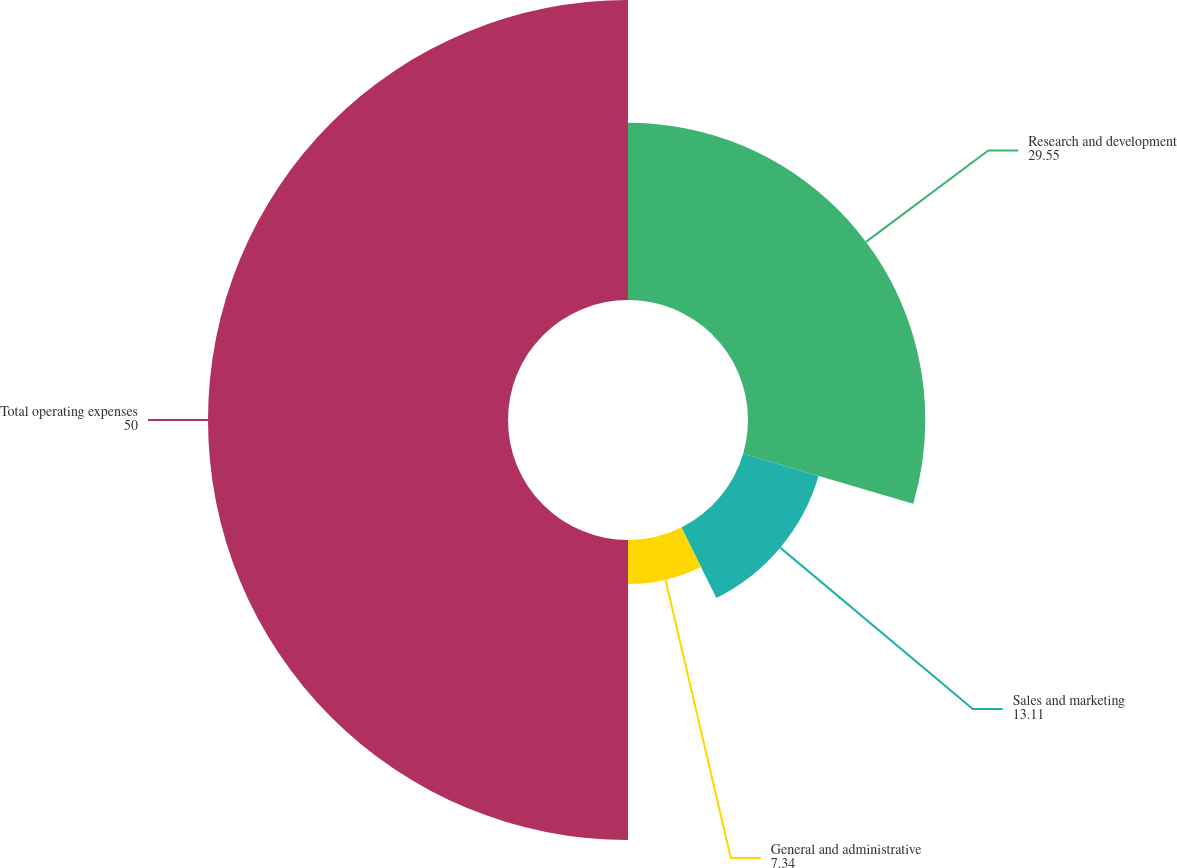Convert chart to OTSL. <chart><loc_0><loc_0><loc_500><loc_500><pie_chart><fcel>Research and development<fcel>Sales and marketing<fcel>General and administrative<fcel>Total operating expenses<nl><fcel>29.55%<fcel>13.11%<fcel>7.34%<fcel>50.0%<nl></chart> 